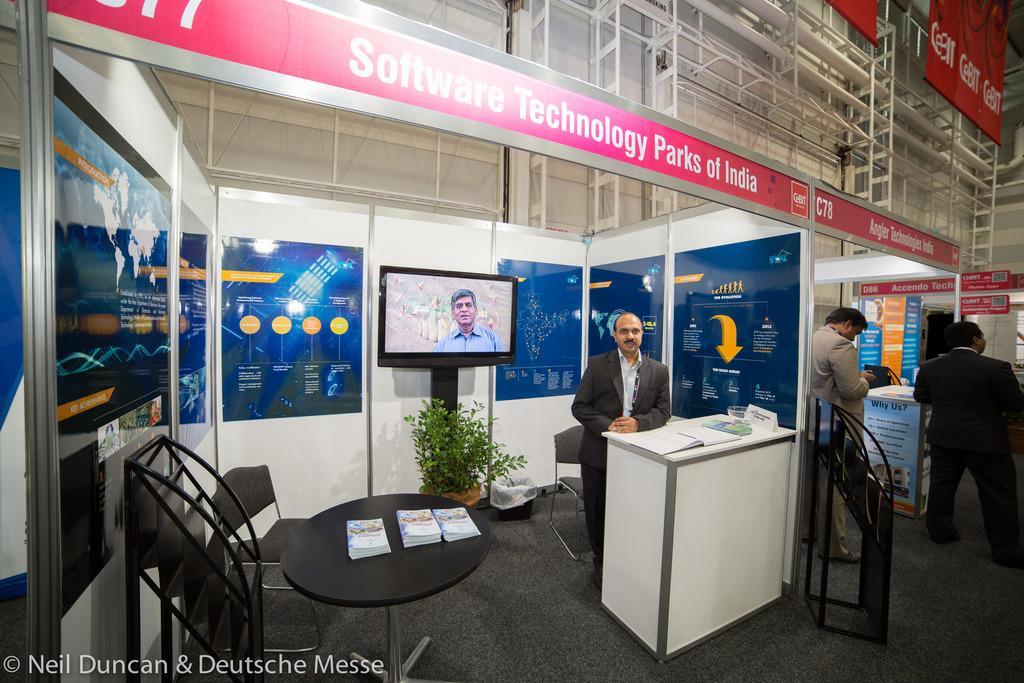In one or two sentences, can you explain what this image depicts? In this picture there are three person standing. There is a book and there is a board and glass on the table. At the back there is a television and there is a picture of a person on the screen and there are boards and there is text on the boards and there are chairs and there is a plant, dustbin. There are books on the table and there is an object. At the bottom there is a mat. At the top there are boards and there is text on the boards. 